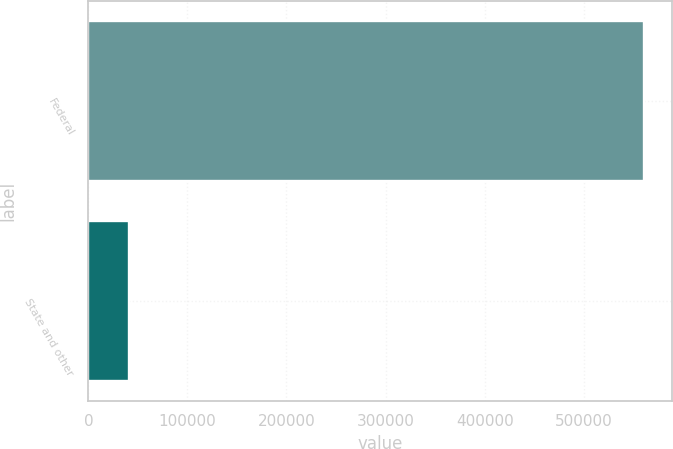Convert chart. <chart><loc_0><loc_0><loc_500><loc_500><bar_chart><fcel>Federal<fcel>State and other<nl><fcel>561322<fcel>41207<nl></chart> 